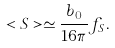<formula> <loc_0><loc_0><loc_500><loc_500>< S > \simeq \frac { b _ { 0 } } { 1 6 \pi } f _ { S } .</formula> 